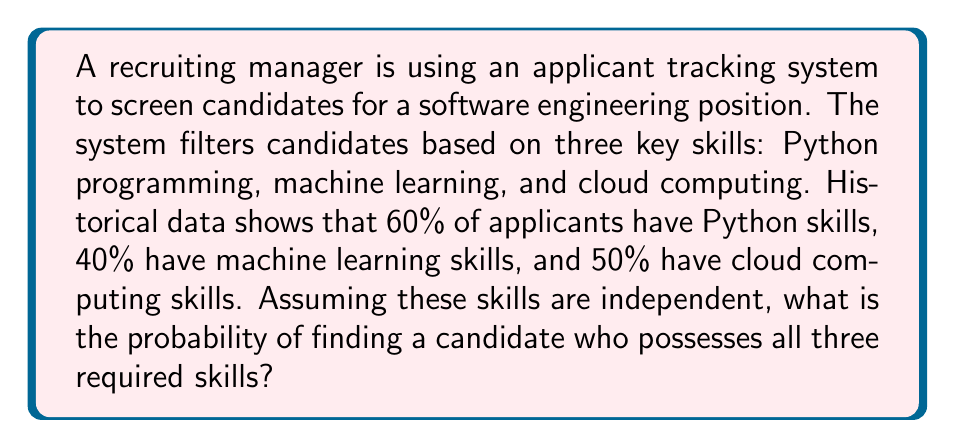Help me with this question. Let's approach this step-by-step:

1) Let's define our events:
   P = Event that a candidate has Python skills
   M = Event that a candidate has machine learning skills
   C = Event that a candidate has cloud computing skills

2) We're given the following probabilities:
   $P(P) = 0.60$
   $P(M) = 0.40$
   $P(C) = 0.50$

3) We need to find the probability of a candidate having all three skills. This is the intersection of these three events:
   $P(P \cap M \cap C)$

4) Since we're told these skills are independent, we can use the multiplication rule for independent events:
   $P(P \cap M \cap C) = P(P) \times P(M) \times P(C)$

5) Now, let's substitute the values:
   $P(P \cap M \cap C) = 0.60 \times 0.40 \times 0.50$

6) Calculate:
   $P(P \cap M \cap C) = 0.12$

Therefore, the probability of finding a candidate with all three required skills is 0.12 or 12%.
Answer: 0.12 